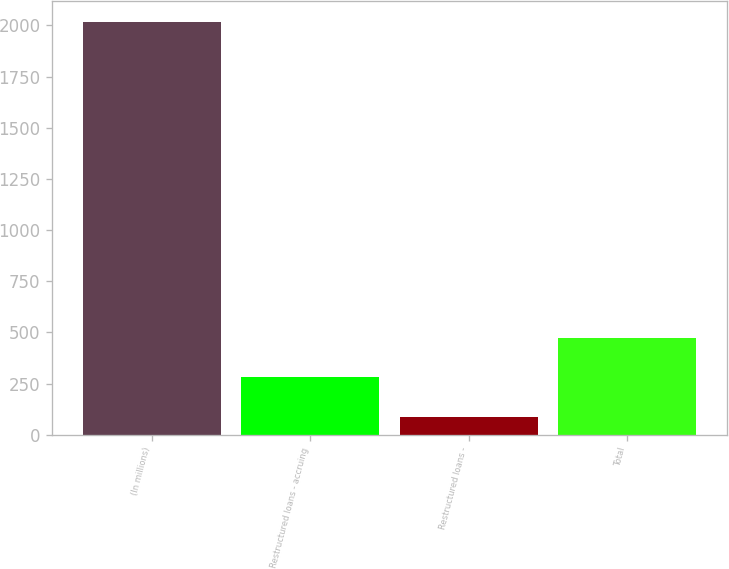<chart> <loc_0><loc_0><loc_500><loc_500><bar_chart><fcel>(In millions)<fcel>Restructured loans - accruing<fcel>Restructured loans -<fcel>Total<nl><fcel>2017<fcel>280<fcel>87<fcel>473<nl></chart> 